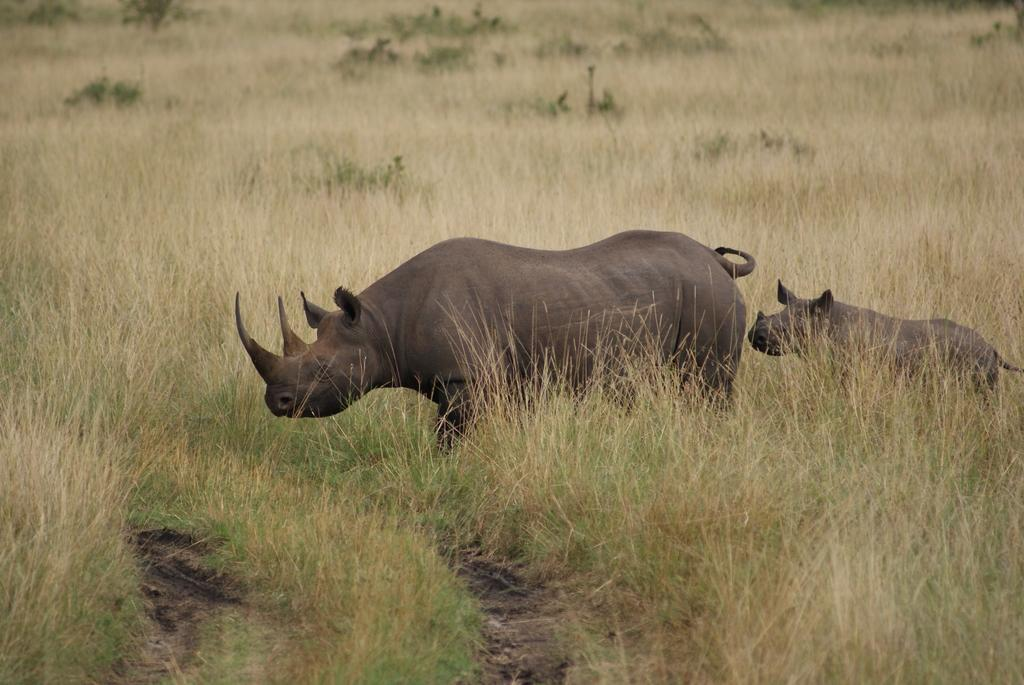What type of animals are in the image? There are rhinos in the image. What type of vegetation is visible in the image? There are plants and grass in the image. What type of star can be seen in the image? There is no star present in the image; it features rhinos, plants, and grass. How many mice are visible in the image? There are no mice present in the image. 